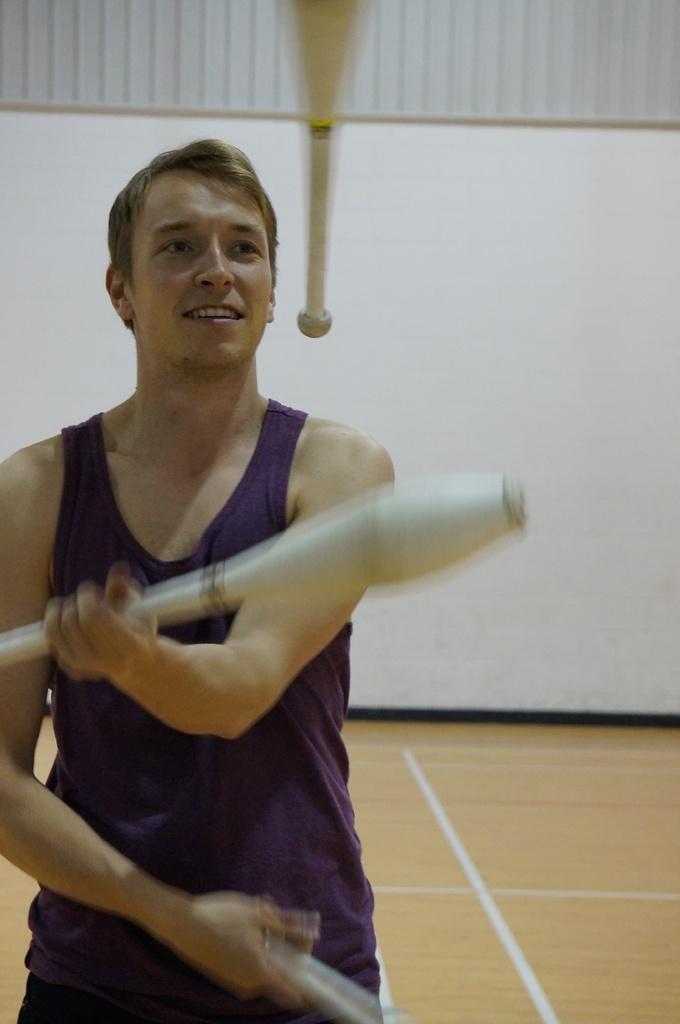In one or two sentences, can you explain what this image depicts? This is the picture of a person who is juggling with the things which are in white color. 